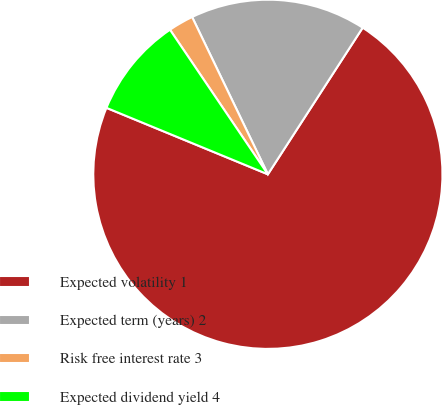Convert chart to OTSL. <chart><loc_0><loc_0><loc_500><loc_500><pie_chart><fcel>Expected volatility 1<fcel>Expected term (years) 2<fcel>Risk free interest rate 3<fcel>Expected dividend yield 4<nl><fcel>72.08%<fcel>16.28%<fcel>2.33%<fcel>9.31%<nl></chart> 